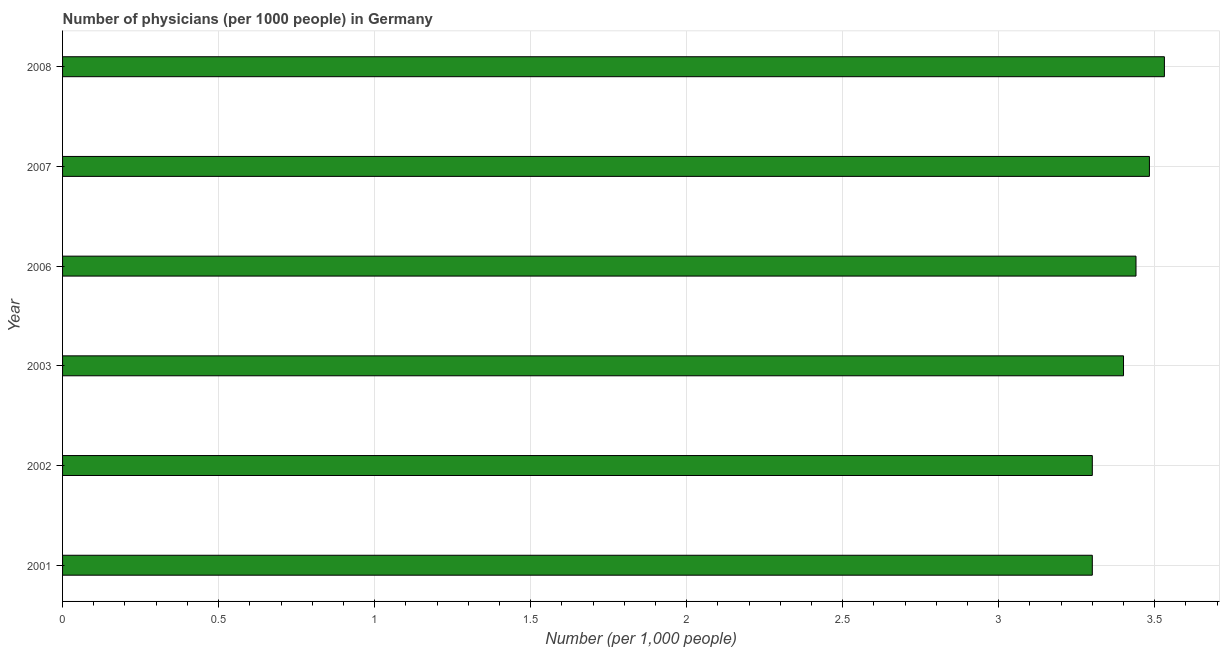Does the graph contain grids?
Offer a terse response. Yes. What is the title of the graph?
Make the answer very short. Number of physicians (per 1000 people) in Germany. What is the label or title of the X-axis?
Ensure brevity in your answer.  Number (per 1,0 people). What is the number of physicians in 2006?
Provide a succinct answer. 3.44. Across all years, what is the maximum number of physicians?
Offer a very short reply. 3.53. In which year was the number of physicians maximum?
Your answer should be compact. 2008. In which year was the number of physicians minimum?
Keep it short and to the point. 2001. What is the sum of the number of physicians?
Your answer should be compact. 20.45. What is the difference between the number of physicians in 2002 and 2003?
Give a very brief answer. -0.1. What is the average number of physicians per year?
Your answer should be compact. 3.41. What is the median number of physicians?
Make the answer very short. 3.42. In how many years, is the number of physicians greater than 2.6 ?
Offer a very short reply. 6. Do a majority of the years between 2002 and 2007 (inclusive) have number of physicians greater than 2.8 ?
Your answer should be very brief. Yes. Is the number of physicians in 2001 less than that in 2006?
Give a very brief answer. Yes. What is the difference between the highest and the second highest number of physicians?
Your answer should be compact. 0.05. What is the difference between the highest and the lowest number of physicians?
Give a very brief answer. 0.23. In how many years, is the number of physicians greater than the average number of physicians taken over all years?
Your answer should be very brief. 3. How many bars are there?
Give a very brief answer. 6. What is the difference between two consecutive major ticks on the X-axis?
Provide a succinct answer. 0.5. Are the values on the major ticks of X-axis written in scientific E-notation?
Your answer should be very brief. No. What is the Number (per 1,000 people) in 2001?
Make the answer very short. 3.3. What is the Number (per 1,000 people) in 2002?
Your answer should be very brief. 3.3. What is the Number (per 1,000 people) of 2006?
Offer a very short reply. 3.44. What is the Number (per 1,000 people) of 2007?
Your answer should be very brief. 3.48. What is the Number (per 1,000 people) in 2008?
Provide a succinct answer. 3.53. What is the difference between the Number (per 1,000 people) in 2001 and 2002?
Give a very brief answer. 0. What is the difference between the Number (per 1,000 people) in 2001 and 2003?
Offer a terse response. -0.1. What is the difference between the Number (per 1,000 people) in 2001 and 2006?
Offer a terse response. -0.14. What is the difference between the Number (per 1,000 people) in 2001 and 2007?
Provide a short and direct response. -0.18. What is the difference between the Number (per 1,000 people) in 2001 and 2008?
Keep it short and to the point. -0.23. What is the difference between the Number (per 1,000 people) in 2002 and 2003?
Provide a short and direct response. -0.1. What is the difference between the Number (per 1,000 people) in 2002 and 2006?
Provide a succinct answer. -0.14. What is the difference between the Number (per 1,000 people) in 2002 and 2007?
Keep it short and to the point. -0.18. What is the difference between the Number (per 1,000 people) in 2002 and 2008?
Provide a short and direct response. -0.23. What is the difference between the Number (per 1,000 people) in 2003 and 2006?
Provide a short and direct response. -0.04. What is the difference between the Number (per 1,000 people) in 2003 and 2007?
Provide a short and direct response. -0.08. What is the difference between the Number (per 1,000 people) in 2003 and 2008?
Offer a very short reply. -0.13. What is the difference between the Number (per 1,000 people) in 2006 and 2007?
Keep it short and to the point. -0.04. What is the difference between the Number (per 1,000 people) in 2006 and 2008?
Provide a succinct answer. -0.09. What is the difference between the Number (per 1,000 people) in 2007 and 2008?
Provide a short and direct response. -0.05. What is the ratio of the Number (per 1,000 people) in 2001 to that in 2007?
Your answer should be compact. 0.95. What is the ratio of the Number (per 1,000 people) in 2001 to that in 2008?
Provide a succinct answer. 0.94. What is the ratio of the Number (per 1,000 people) in 2002 to that in 2003?
Offer a very short reply. 0.97. What is the ratio of the Number (per 1,000 people) in 2002 to that in 2007?
Your answer should be very brief. 0.95. What is the ratio of the Number (per 1,000 people) in 2002 to that in 2008?
Give a very brief answer. 0.94. What is the ratio of the Number (per 1,000 people) in 2003 to that in 2006?
Provide a short and direct response. 0.99. What is the ratio of the Number (per 1,000 people) in 2003 to that in 2007?
Your answer should be very brief. 0.98. What is the ratio of the Number (per 1,000 people) in 2006 to that in 2007?
Ensure brevity in your answer.  0.99. What is the ratio of the Number (per 1,000 people) in 2006 to that in 2008?
Make the answer very short. 0.97. 